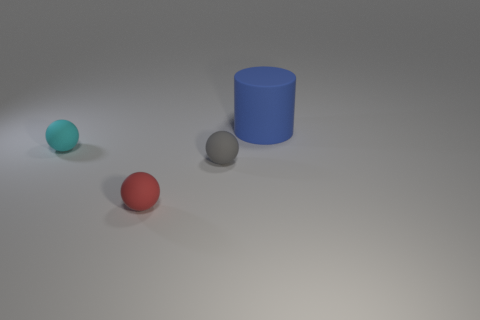How big is the rubber object that is right of the tiny ball right of the tiny sphere in front of the small gray rubber object?
Offer a very short reply. Large. The red thing is what size?
Offer a terse response. Small. There is a object behind the sphere behind the gray object; are there any tiny gray rubber things in front of it?
Make the answer very short. Yes. What number of big objects are either red matte cylinders or blue objects?
Provide a succinct answer. 1. Is there anything else that has the same color as the rubber cylinder?
Make the answer very short. No. There is a ball that is to the right of the red matte thing; does it have the same size as the small red ball?
Provide a succinct answer. Yes. There is a small matte sphere that is in front of the small rubber sphere that is right of the tiny sphere that is in front of the tiny gray matte sphere; what color is it?
Your response must be concise. Red. What color is the rubber cylinder?
Your answer should be compact. Blue. There is a cyan object that is the same shape as the gray matte object; what material is it?
Offer a very short reply. Rubber. Do the gray sphere and the cyan sphere have the same material?
Ensure brevity in your answer.  Yes. 